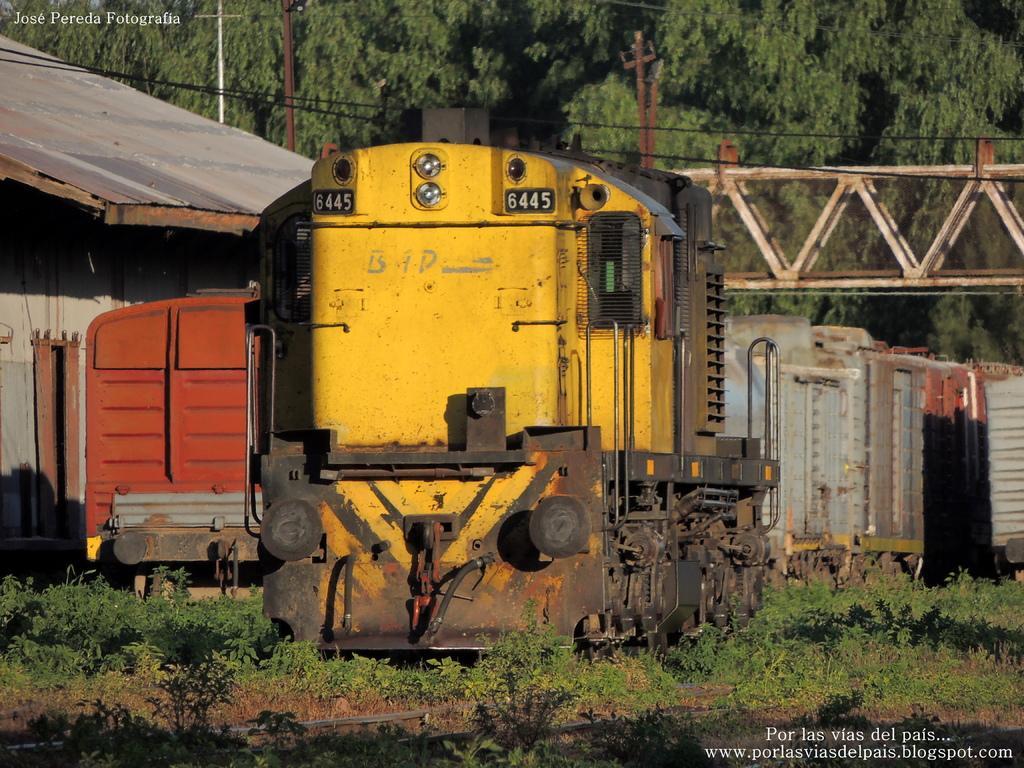Please provide a concise description of this image. In the picture there are few compartments of a trains are kept on a land and behind those compartments there is a bridge and behind the bridge there a many trees. 